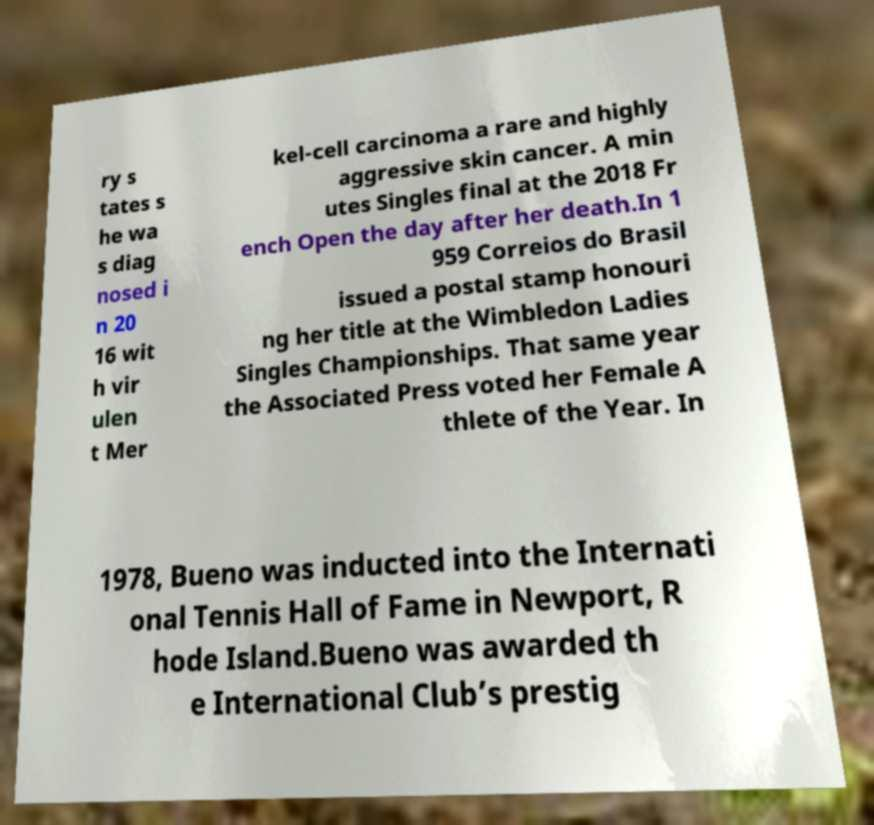Please identify and transcribe the text found in this image. ry s tates s he wa s diag nosed i n 20 16 wit h vir ulen t Mer kel-cell carcinoma a rare and highly aggressive skin cancer. A min utes Singles final at the 2018 Fr ench Open the day after her death.In 1 959 Correios do Brasil issued a postal stamp honouri ng her title at the Wimbledon Ladies Singles Championships. That same year the Associated Press voted her Female A thlete of the Year. In 1978, Bueno was inducted into the Internati onal Tennis Hall of Fame in Newport, R hode Island.Bueno was awarded th e International Club’s prestig 